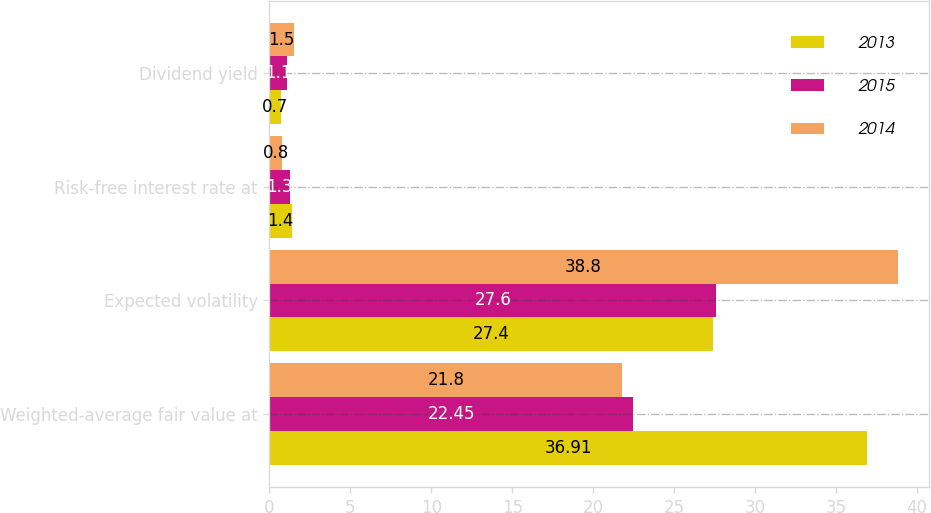<chart> <loc_0><loc_0><loc_500><loc_500><stacked_bar_chart><ecel><fcel>Weighted-average fair value at<fcel>Expected volatility<fcel>Risk-free interest rate at<fcel>Dividend yield<nl><fcel>2013<fcel>36.91<fcel>27.4<fcel>1.4<fcel>0.7<nl><fcel>2015<fcel>22.45<fcel>27.6<fcel>1.3<fcel>1.1<nl><fcel>2014<fcel>21.8<fcel>38.8<fcel>0.8<fcel>1.5<nl></chart> 